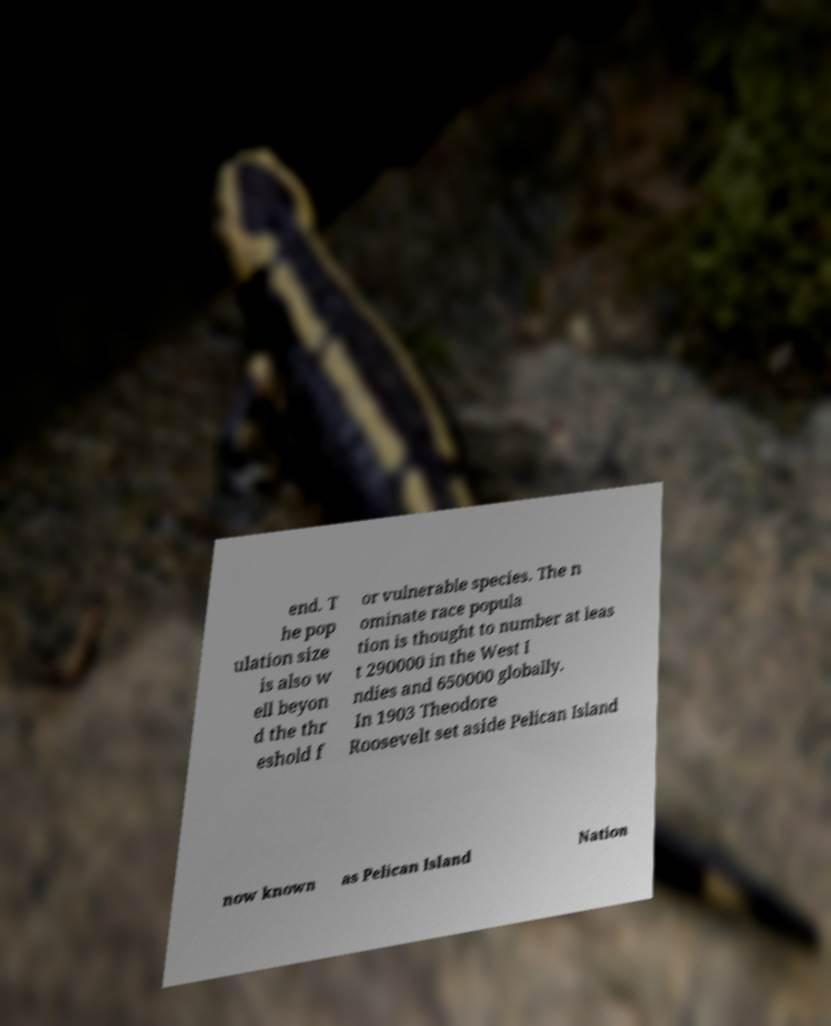Could you assist in decoding the text presented in this image and type it out clearly? end. T he pop ulation size is also w ell beyon d the thr eshold f or vulnerable species. The n ominate race popula tion is thought to number at leas t 290000 in the West I ndies and 650000 globally. In 1903 Theodore Roosevelt set aside Pelican Island now known as Pelican Island Nation 